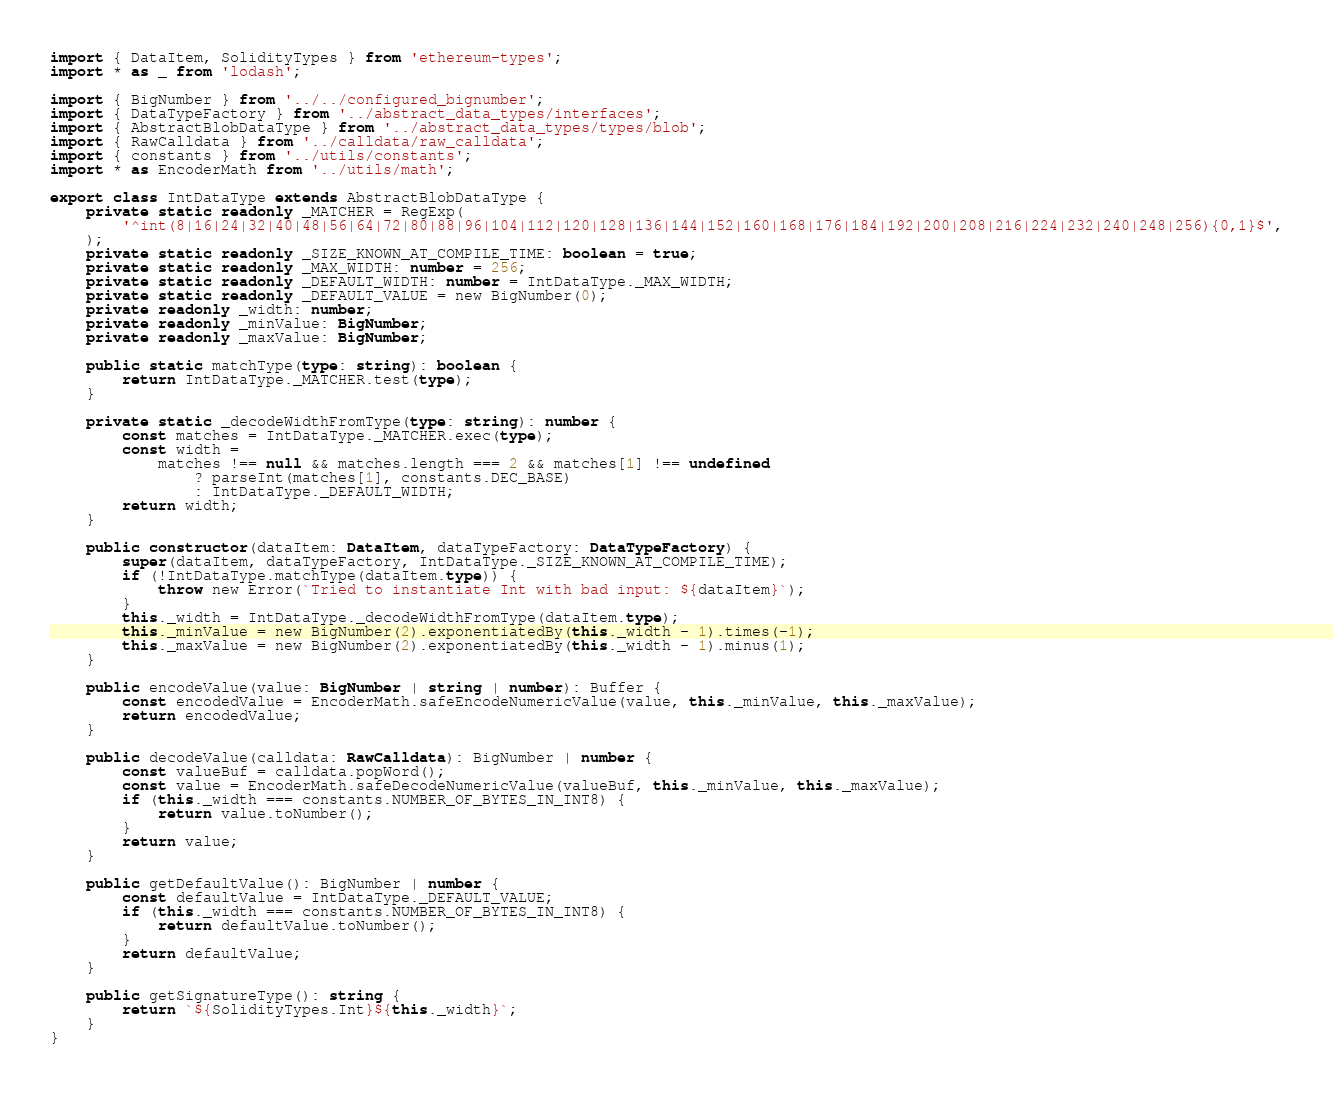<code> <loc_0><loc_0><loc_500><loc_500><_TypeScript_>import { DataItem, SolidityTypes } from 'ethereum-types';
import * as _ from 'lodash';

import { BigNumber } from '../../configured_bignumber';
import { DataTypeFactory } from '../abstract_data_types/interfaces';
import { AbstractBlobDataType } from '../abstract_data_types/types/blob';
import { RawCalldata } from '../calldata/raw_calldata';
import { constants } from '../utils/constants';
import * as EncoderMath from '../utils/math';

export class IntDataType extends AbstractBlobDataType {
    private static readonly _MATCHER = RegExp(
        '^int(8|16|24|32|40|48|56|64|72|80|88|96|104|112|120|128|136|144|152|160|168|176|184|192|200|208|216|224|232|240|248|256){0,1}$',
    );
    private static readonly _SIZE_KNOWN_AT_COMPILE_TIME: boolean = true;
    private static readonly _MAX_WIDTH: number = 256;
    private static readonly _DEFAULT_WIDTH: number = IntDataType._MAX_WIDTH;
    private static readonly _DEFAULT_VALUE = new BigNumber(0);
    private readonly _width: number;
    private readonly _minValue: BigNumber;
    private readonly _maxValue: BigNumber;

    public static matchType(type: string): boolean {
        return IntDataType._MATCHER.test(type);
    }

    private static _decodeWidthFromType(type: string): number {
        const matches = IntDataType._MATCHER.exec(type);
        const width =
            matches !== null && matches.length === 2 && matches[1] !== undefined
                ? parseInt(matches[1], constants.DEC_BASE)
                : IntDataType._DEFAULT_WIDTH;
        return width;
    }

    public constructor(dataItem: DataItem, dataTypeFactory: DataTypeFactory) {
        super(dataItem, dataTypeFactory, IntDataType._SIZE_KNOWN_AT_COMPILE_TIME);
        if (!IntDataType.matchType(dataItem.type)) {
            throw new Error(`Tried to instantiate Int with bad input: ${dataItem}`);
        }
        this._width = IntDataType._decodeWidthFromType(dataItem.type);
        this._minValue = new BigNumber(2).exponentiatedBy(this._width - 1).times(-1);
        this._maxValue = new BigNumber(2).exponentiatedBy(this._width - 1).minus(1);
    }

    public encodeValue(value: BigNumber | string | number): Buffer {
        const encodedValue = EncoderMath.safeEncodeNumericValue(value, this._minValue, this._maxValue);
        return encodedValue;
    }

    public decodeValue(calldata: RawCalldata): BigNumber | number {
        const valueBuf = calldata.popWord();
        const value = EncoderMath.safeDecodeNumericValue(valueBuf, this._minValue, this._maxValue);
        if (this._width === constants.NUMBER_OF_BYTES_IN_INT8) {
            return value.toNumber();
        }
        return value;
    }

    public getDefaultValue(): BigNumber | number {
        const defaultValue = IntDataType._DEFAULT_VALUE;
        if (this._width === constants.NUMBER_OF_BYTES_IN_INT8) {
            return defaultValue.toNumber();
        }
        return defaultValue;
    }

    public getSignatureType(): string {
        return `${SolidityTypes.Int}${this._width}`;
    }
}
</code> 